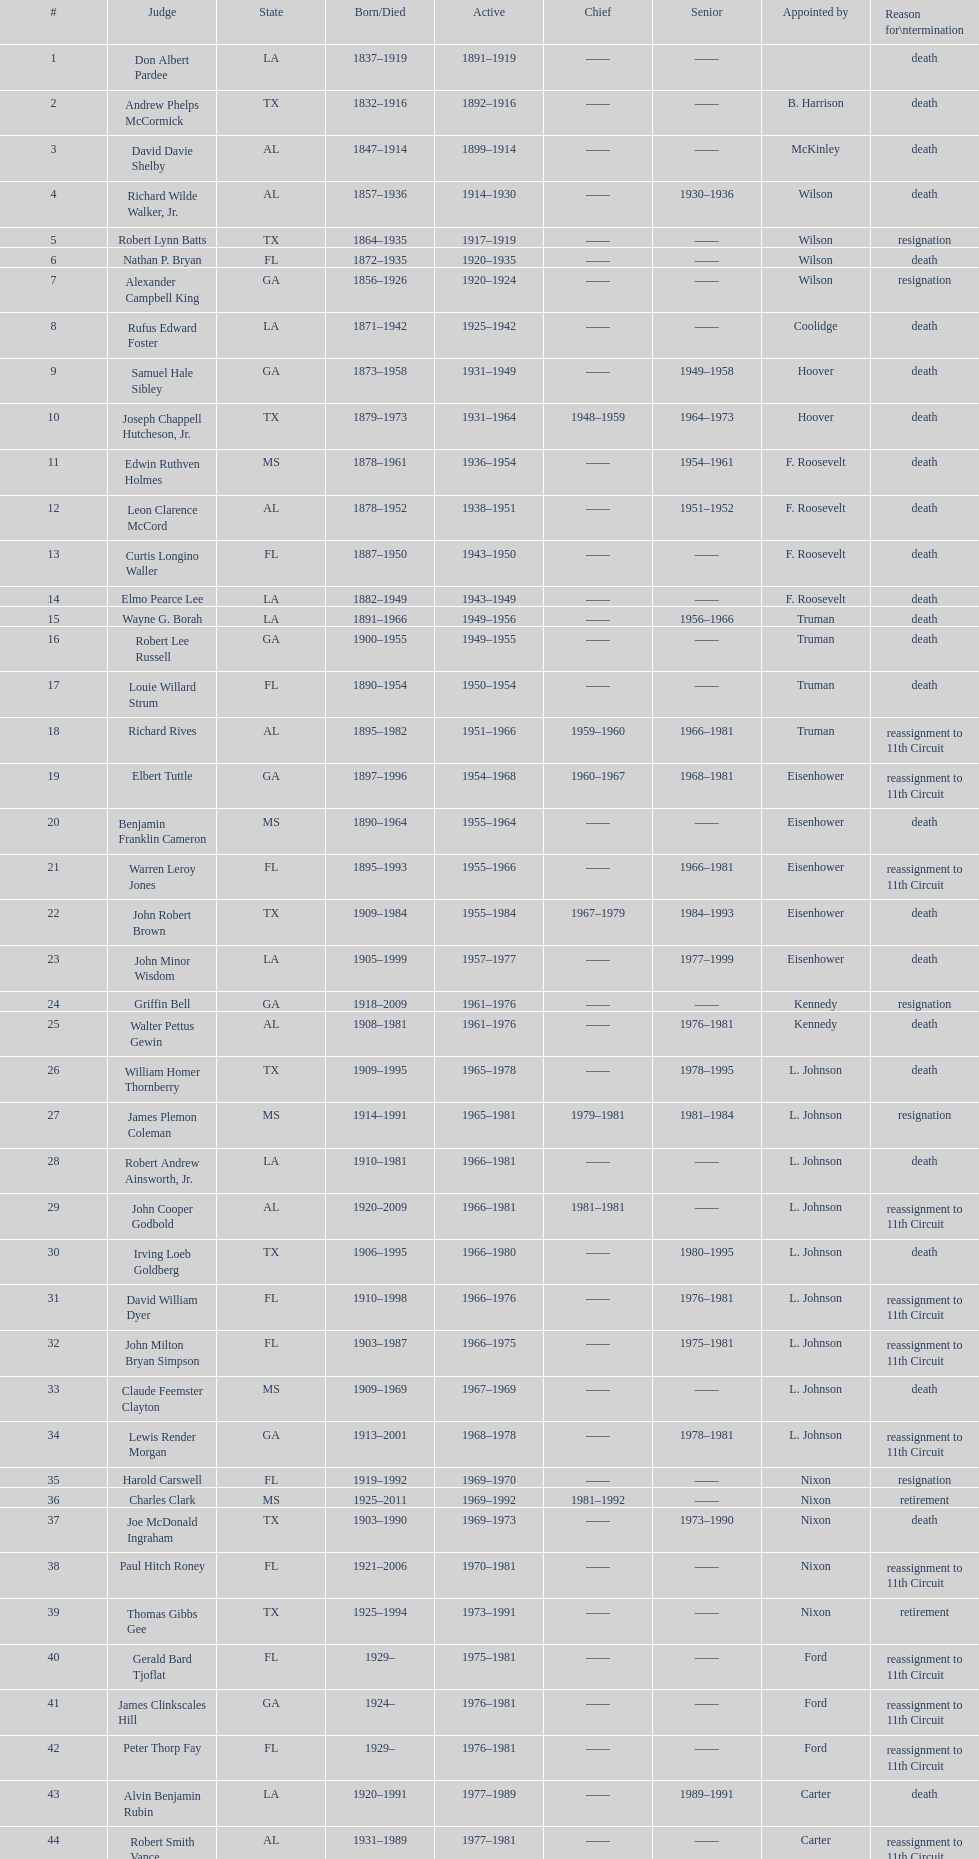Specify a state referred to at least 4 times. TX. 